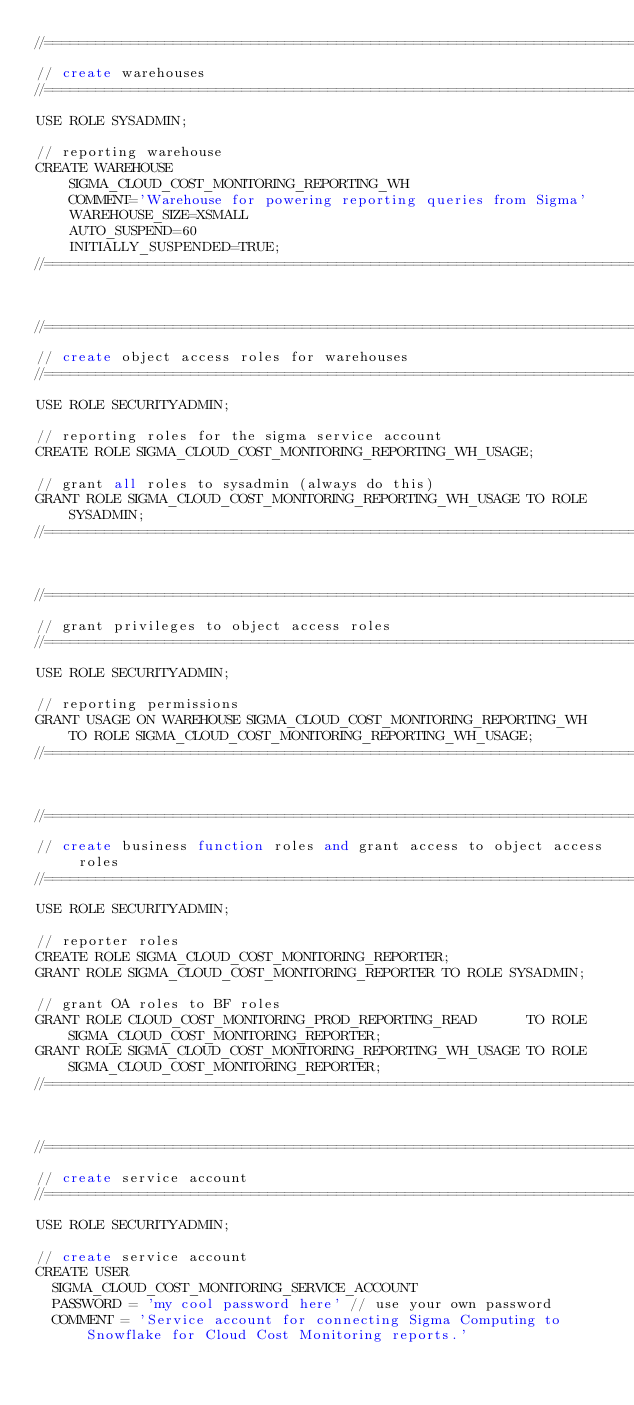<code> <loc_0><loc_0><loc_500><loc_500><_SQL_>//=============================================================================
// create warehouses
//=============================================================================
USE ROLE SYSADMIN;

// reporting warehouse
CREATE WAREHOUSE
    SIGMA_CLOUD_COST_MONITORING_REPORTING_WH
    COMMENT='Warehouse for powering reporting queries from Sigma'
    WAREHOUSE_SIZE=XSMALL
    AUTO_SUSPEND=60
    INITIALLY_SUSPENDED=TRUE;
//=============================================================================


//=============================================================================
// create object access roles for warehouses
//=============================================================================
USE ROLE SECURITYADMIN;

// reporting roles for the sigma service account
CREATE ROLE SIGMA_CLOUD_COST_MONITORING_REPORTING_WH_USAGE;

// grant all roles to sysadmin (always do this)
GRANT ROLE SIGMA_CLOUD_COST_MONITORING_REPORTING_WH_USAGE TO ROLE SYSADMIN;
//=============================================================================


//=============================================================================
// grant privileges to object access roles
//=============================================================================
USE ROLE SECURITYADMIN;

// reporting permissions
GRANT USAGE ON WAREHOUSE SIGMA_CLOUD_COST_MONITORING_REPORTING_WH TO ROLE SIGMA_CLOUD_COST_MONITORING_REPORTING_WH_USAGE;
//=============================================================================


//=============================================================================
// create business function roles and grant access to object access roles
//=============================================================================
USE ROLE SECURITYADMIN;
 
// reporter roles
CREATE ROLE SIGMA_CLOUD_COST_MONITORING_REPORTER;
GRANT ROLE SIGMA_CLOUD_COST_MONITORING_REPORTER TO ROLE SYSADMIN;

// grant OA roles to BF roles
GRANT ROLE CLOUD_COST_MONITORING_PROD_REPORTING_READ      TO ROLE SIGMA_CLOUD_COST_MONITORING_REPORTER;
GRANT ROLE SIGMA_CLOUD_COST_MONITORING_REPORTING_WH_USAGE TO ROLE SIGMA_CLOUD_COST_MONITORING_REPORTER;
//=============================================================================


//=============================================================================
// create service account
//=============================================================================
USE ROLE SECURITYADMIN;
 
// create service account
CREATE USER 
  SIGMA_CLOUD_COST_MONITORING_SERVICE_ACCOUNT
  PASSWORD = 'my cool password here' // use your own password 
  COMMENT = 'Service account for connecting Sigma Computing to Snowflake for Cloud Cost Monitoring reports.'</code> 